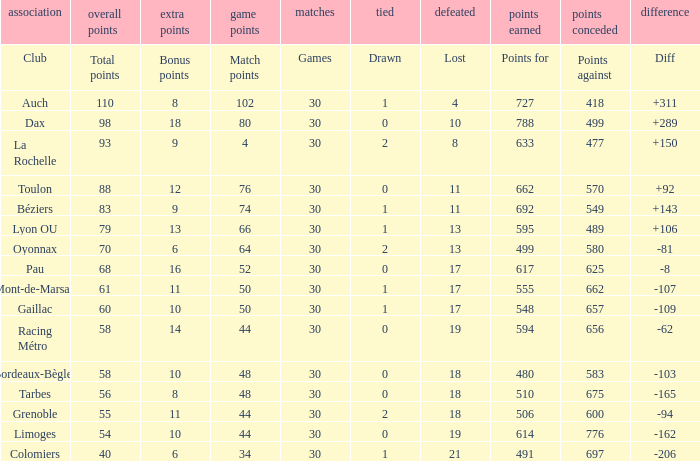What is the value of match points when the points for is 570? 76.0. 